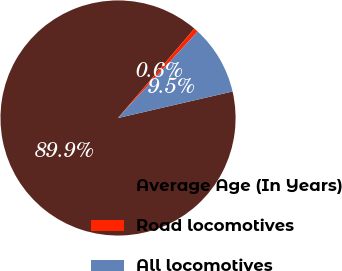<chart> <loc_0><loc_0><loc_500><loc_500><pie_chart><fcel>Average Age (In Years)<fcel>Road locomotives<fcel>All locomotives<nl><fcel>89.87%<fcel>0.6%<fcel>9.53%<nl></chart> 